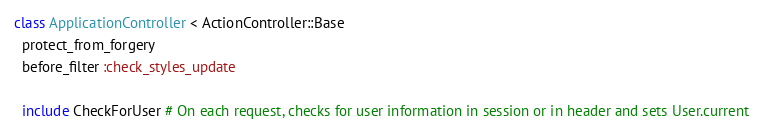Convert code to text. <code><loc_0><loc_0><loc_500><loc_500><_Ruby_>class ApplicationController < ActionController::Base
  protect_from_forgery
  before_filter :check_styles_update

  include CheckForUser # On each request, checks for user information in session or in header and sets User.current
</code> 